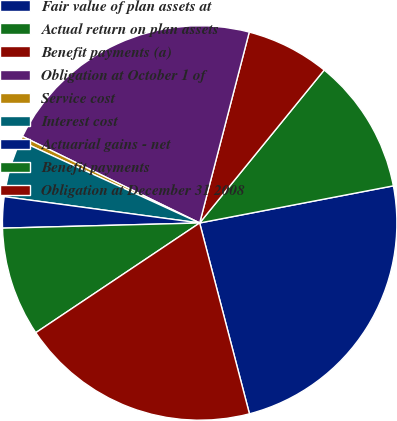Convert chart to OTSL. <chart><loc_0><loc_0><loc_500><loc_500><pie_chart><fcel>Fair value of plan assets at<fcel>Actual return on plan assets<fcel>Benefit payments (a)<fcel>Obligation at October 1 of<fcel>Service cost<fcel>Interest cost<fcel>Actuarial gains - net<fcel>Benefit payments<fcel>Obligation at December 31 2008<nl><fcel>23.95%<fcel>11.11%<fcel>6.83%<fcel>21.81%<fcel>0.41%<fcel>4.69%<fcel>2.55%<fcel>8.97%<fcel>19.67%<nl></chart> 